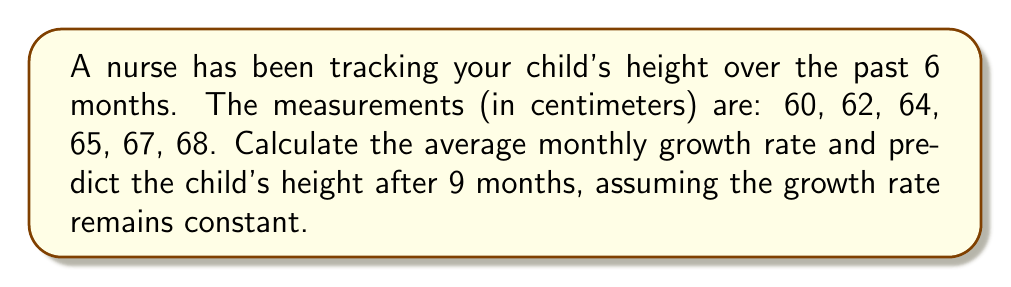Could you help me with this problem? Let's approach this step-by-step:

1) First, we need to calculate the total growth over 6 months:
   Final height - Initial height = 68 cm - 60 cm = 8 cm

2) To find the average monthly growth rate, we divide the total growth by the number of months:
   Average monthly growth rate = $\frac{\text{Total growth}}{\text{Number of months}} = \frac{8 \text{ cm}}{6 \text{ months}} = \frac{4}{3} \text{ cm/month}$

3) Now, to predict the height after 9 months, we need to:
   a) Calculate the additional growth for 3 more months
   b) Add this to the last recorded height

4) Additional growth for 3 months:
   $3 \text{ months} \times \frac{4}{3} \text{ cm/month} = 4 \text{ cm}$

5) Predicted height after 9 months:
   Last recorded height + Additional growth = 68 cm + 4 cm = 72 cm

Therefore, if the growth rate remains constant, the child's predicted height after 9 months would be 72 cm.
Answer: 72 cm 